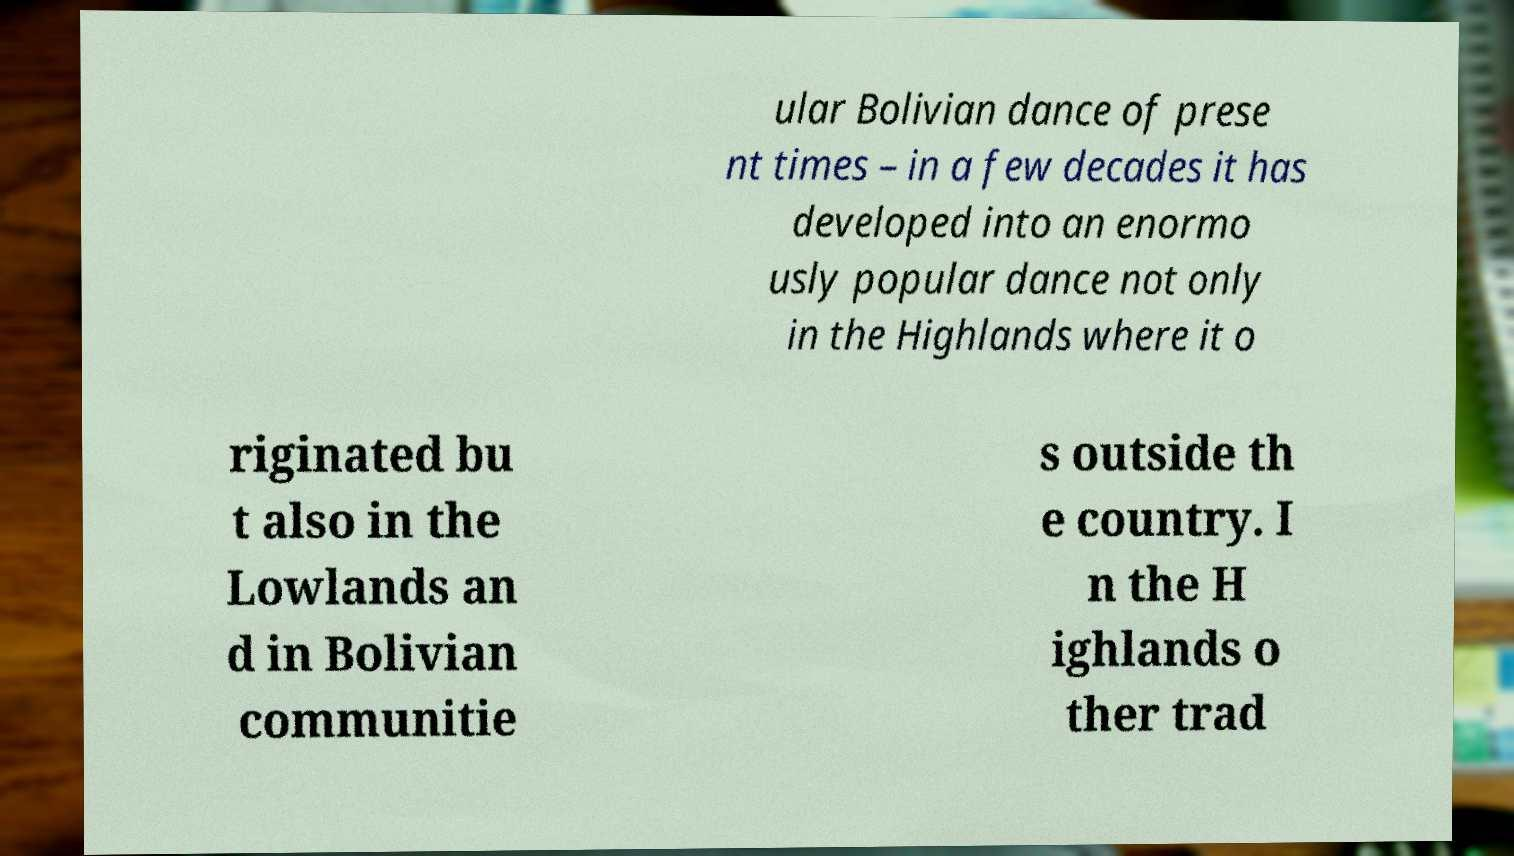For documentation purposes, I need the text within this image transcribed. Could you provide that? ular Bolivian dance of prese nt times – in a few decades it has developed into an enormo usly popular dance not only in the Highlands where it o riginated bu t also in the Lowlands an d in Bolivian communitie s outside th e country. I n the H ighlands o ther trad 